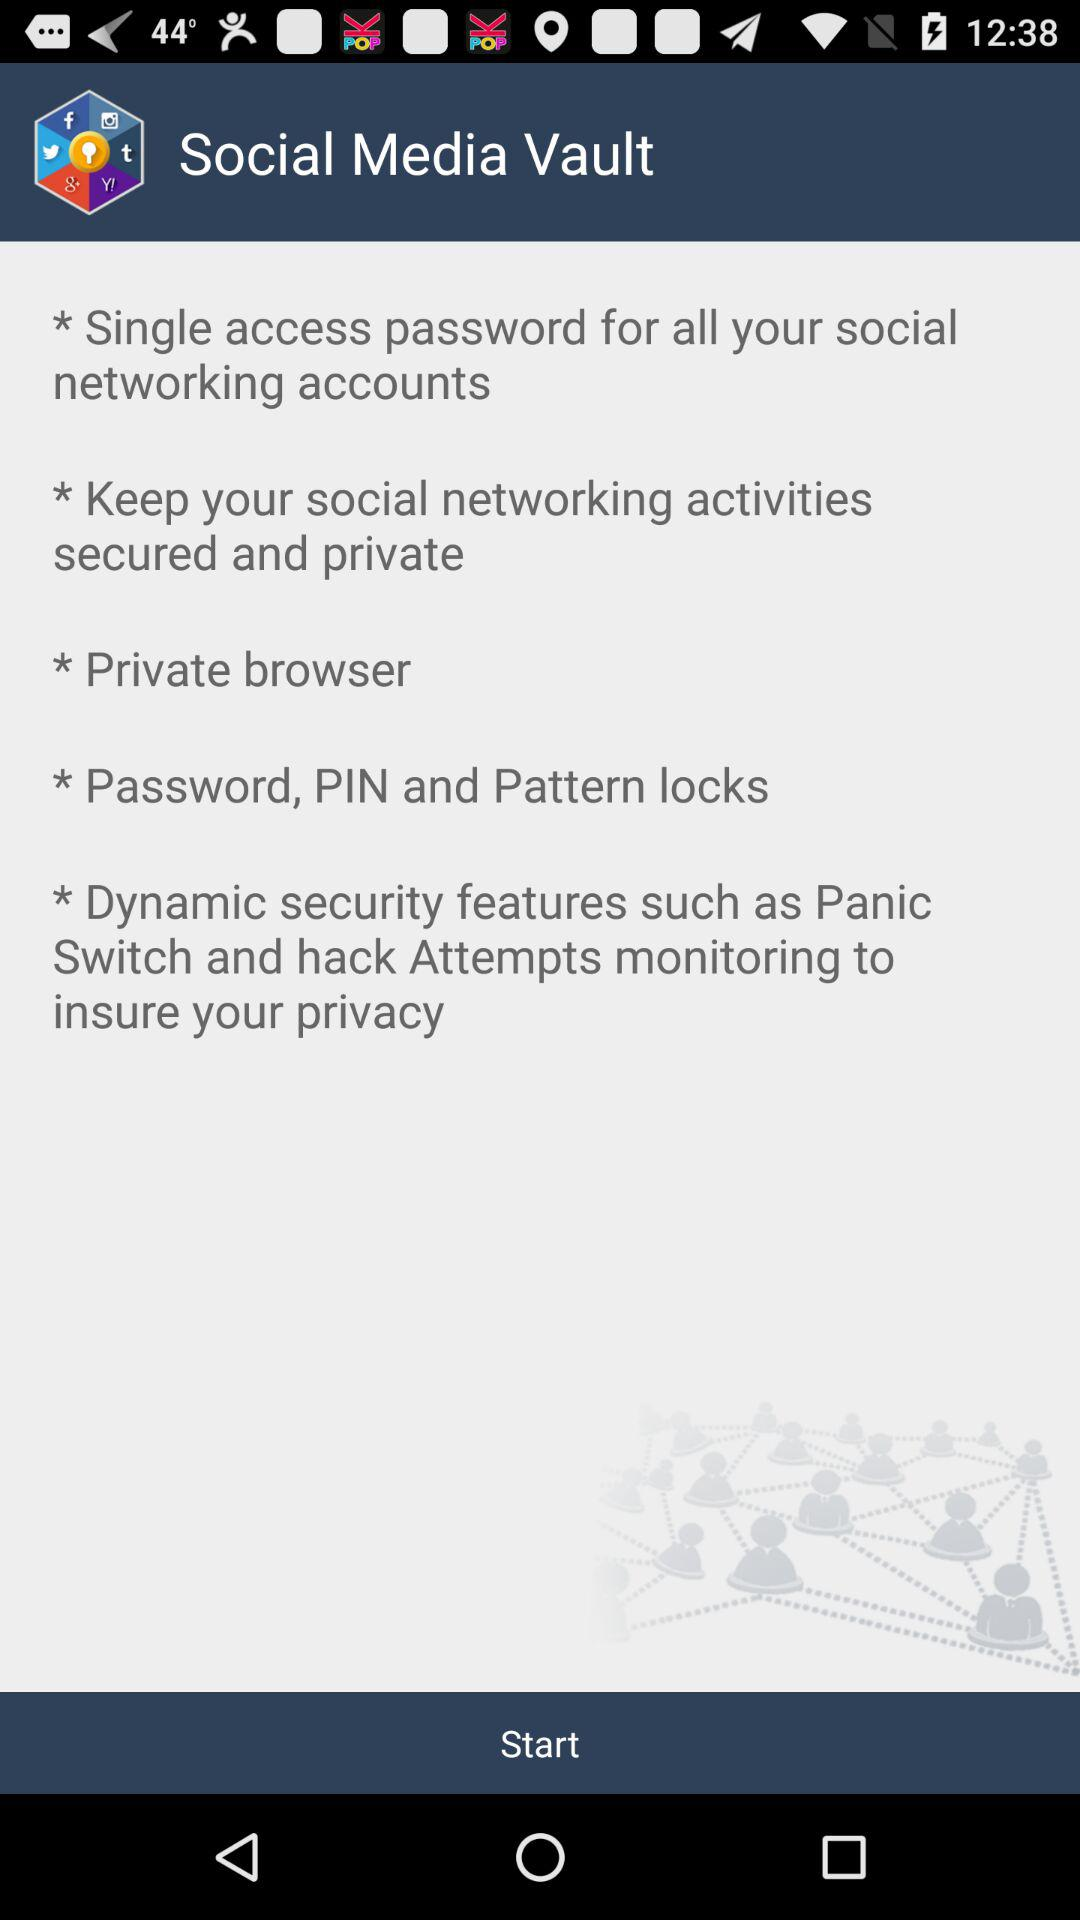What are the dynamic security features? The dynamic security features "Panic Switch and hack Attempts monitoring to insure your privacy". 